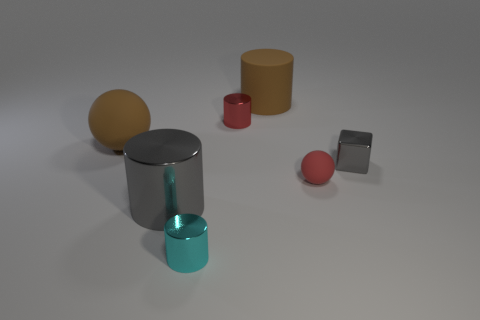Subtract all brown cylinders. How many cylinders are left? 3 Add 1 red rubber blocks. How many objects exist? 8 Subtract all red spheres. How many spheres are left? 1 Subtract 1 cubes. How many cubes are left? 0 Subtract all red spheres. Subtract all gray cylinders. How many spheres are left? 1 Subtract all green cubes. How many red cylinders are left? 1 Subtract all purple rubber cubes. Subtract all brown cylinders. How many objects are left? 6 Add 6 large matte cylinders. How many large matte cylinders are left? 7 Add 7 large matte balls. How many large matte balls exist? 8 Subtract 0 green spheres. How many objects are left? 7 